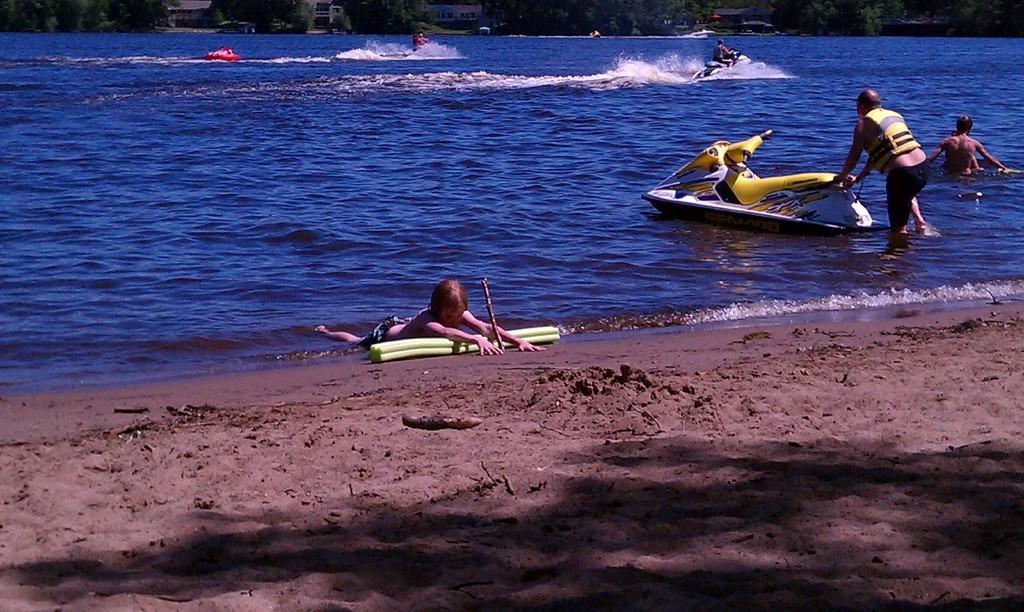What is at the bottom of the image? There is sand at the bottom of the image. What is in the middle of the image? There is water in the middle of the image. What are the people doing on the water? The people are riding water boats on the water. What can be seen at the top of the image? There are trees and buildings at the top of the image. Can you tell me how many flowers are blooming in the water? There are no flowers visible in the water; it contains water boats with people riding them. 